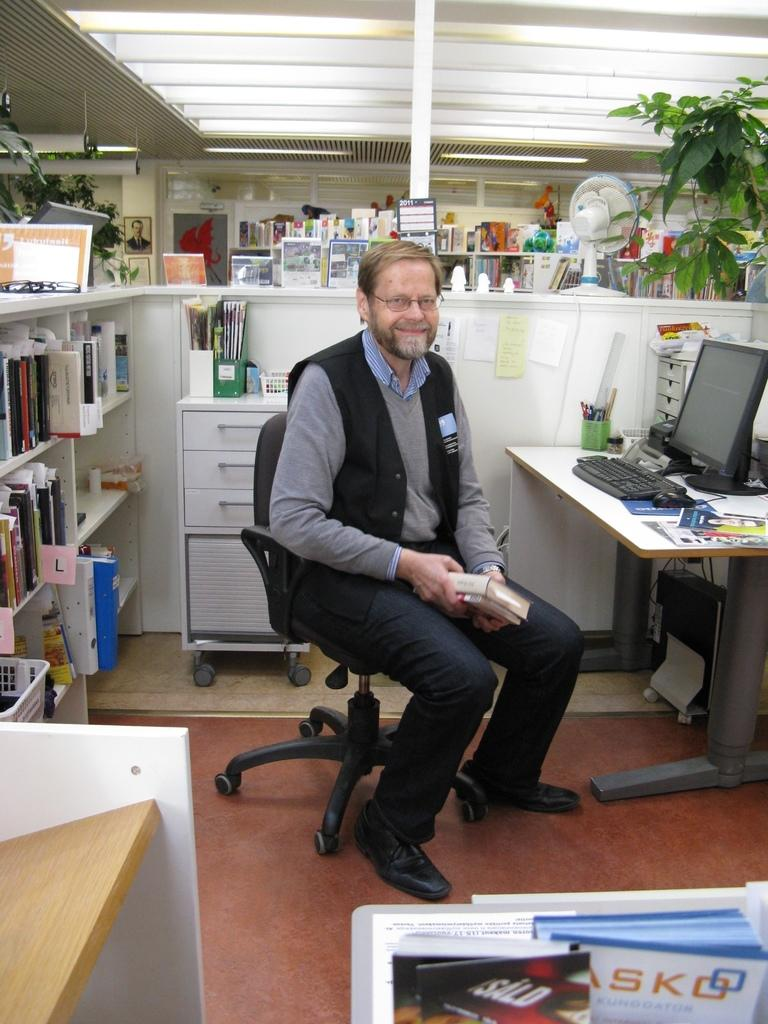<image>
Summarize the visual content of the image. A man sits in his office in front of an alphabetized shelf of materials. 